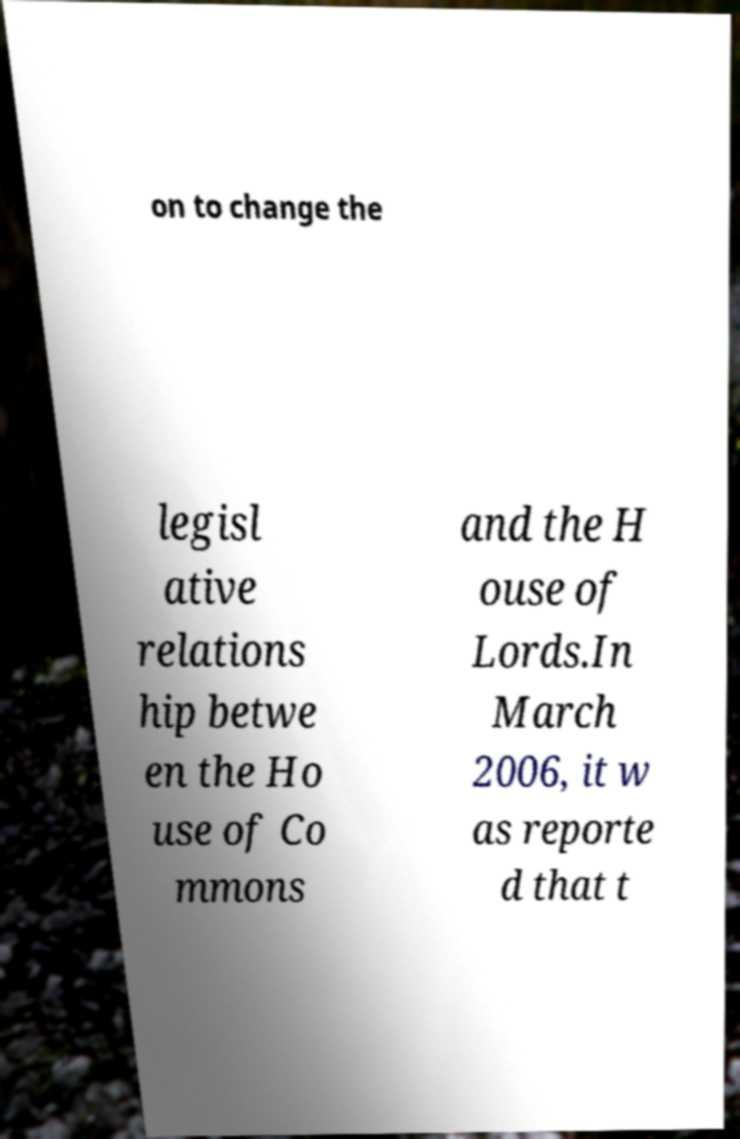What messages or text are displayed in this image? I need them in a readable, typed format. on to change the legisl ative relations hip betwe en the Ho use of Co mmons and the H ouse of Lords.In March 2006, it w as reporte d that t 